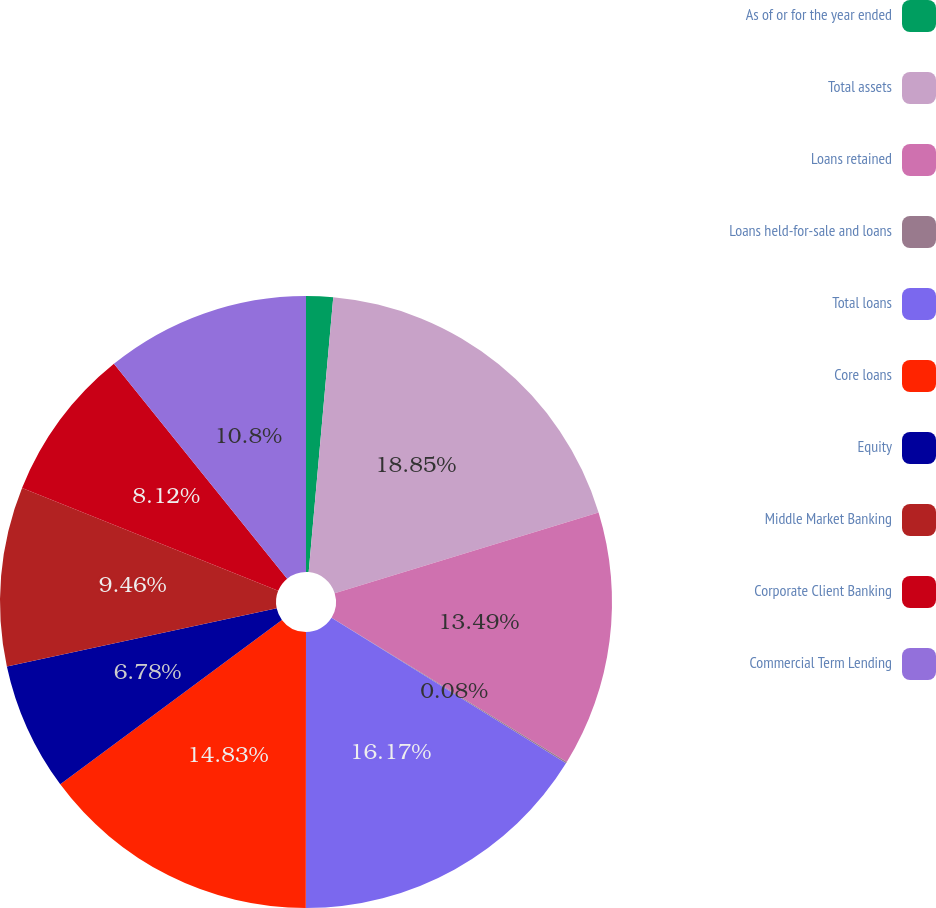Convert chart. <chart><loc_0><loc_0><loc_500><loc_500><pie_chart><fcel>As of or for the year ended<fcel>Total assets<fcel>Loans retained<fcel>Loans held-for-sale and loans<fcel>Total loans<fcel>Core loans<fcel>Equity<fcel>Middle Market Banking<fcel>Corporate Client Banking<fcel>Commercial Term Lending<nl><fcel>1.42%<fcel>18.85%<fcel>13.49%<fcel>0.08%<fcel>16.17%<fcel>14.83%<fcel>6.78%<fcel>9.46%<fcel>8.12%<fcel>10.8%<nl></chart> 